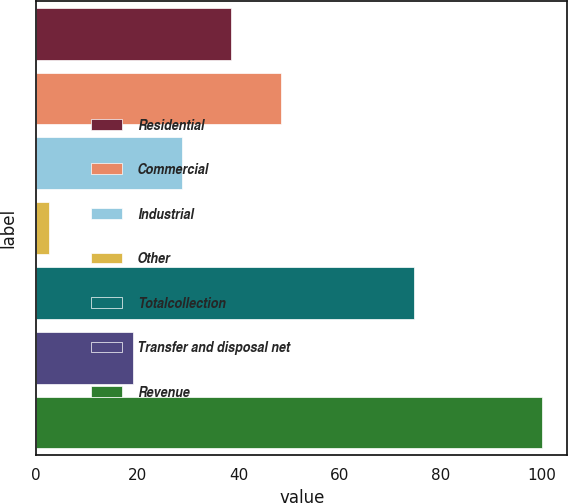Convert chart. <chart><loc_0><loc_0><loc_500><loc_500><bar_chart><fcel>Residential<fcel>Commercial<fcel>Industrial<fcel>Other<fcel>Totalcollection<fcel>Transfer and disposal net<fcel>Revenue<nl><fcel>38.58<fcel>48.32<fcel>28.84<fcel>2.6<fcel>74.7<fcel>19.1<fcel>100<nl></chart> 